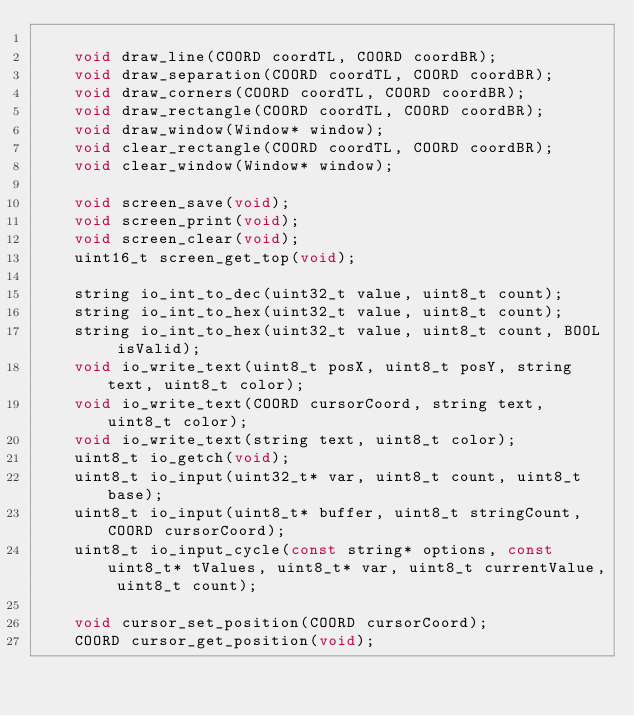<code> <loc_0><loc_0><loc_500><loc_500><_C_>
	void draw_line(COORD coordTL, COORD coordBR);
	void draw_separation(COORD coordTL, COORD coordBR);
	void draw_corners(COORD coordTL, COORD coordBR);
	void draw_rectangle(COORD coordTL, COORD coordBR);
	void draw_window(Window* window);
	void clear_rectangle(COORD coordTL, COORD coordBR);
	void clear_window(Window* window);

	void screen_save(void);
	void screen_print(void);
	void screen_clear(void);
	uint16_t screen_get_top(void);

	string io_int_to_dec(uint32_t value, uint8_t count);
	string io_int_to_hex(uint32_t value, uint8_t count);
	string io_int_to_hex(uint32_t value, uint8_t count, BOOL isValid);
	void io_write_text(uint8_t posX, uint8_t posY, string text, uint8_t color);
	void io_write_text(COORD cursorCoord, string text, uint8_t color);
	void io_write_text(string text, uint8_t color);
	uint8_t io_getch(void);
	uint8_t io_input(uint32_t* var, uint8_t count, uint8_t base);
	uint8_t io_input(uint8_t* buffer, uint8_t stringCount, COORD cursorCoord);
	uint8_t io_input_cycle(const string* options, const uint8_t* tValues, uint8_t* var, uint8_t currentValue, uint8_t count);

	void cursor_set_position(COORD cursorCoord);
	COORD cursor_get_position(void);</code> 